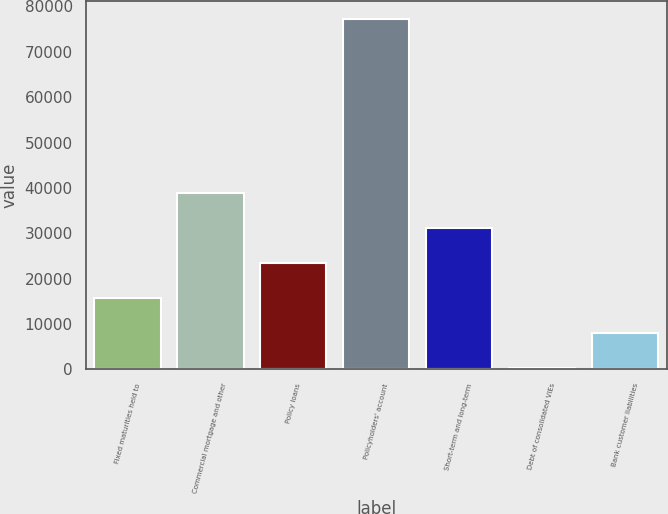<chart> <loc_0><loc_0><loc_500><loc_500><bar_chart><fcel>Fixed maturities held to<fcel>Commercial mortgage and other<fcel>Policy loans<fcel>Policyholders' account<fcel>Short-term and long-term<fcel>Debt of consolidated VIEs<fcel>Bank customer liabilities<nl><fcel>15756.4<fcel>38818<fcel>23443.6<fcel>77254<fcel>31130.8<fcel>382<fcel>8069.2<nl></chart> 